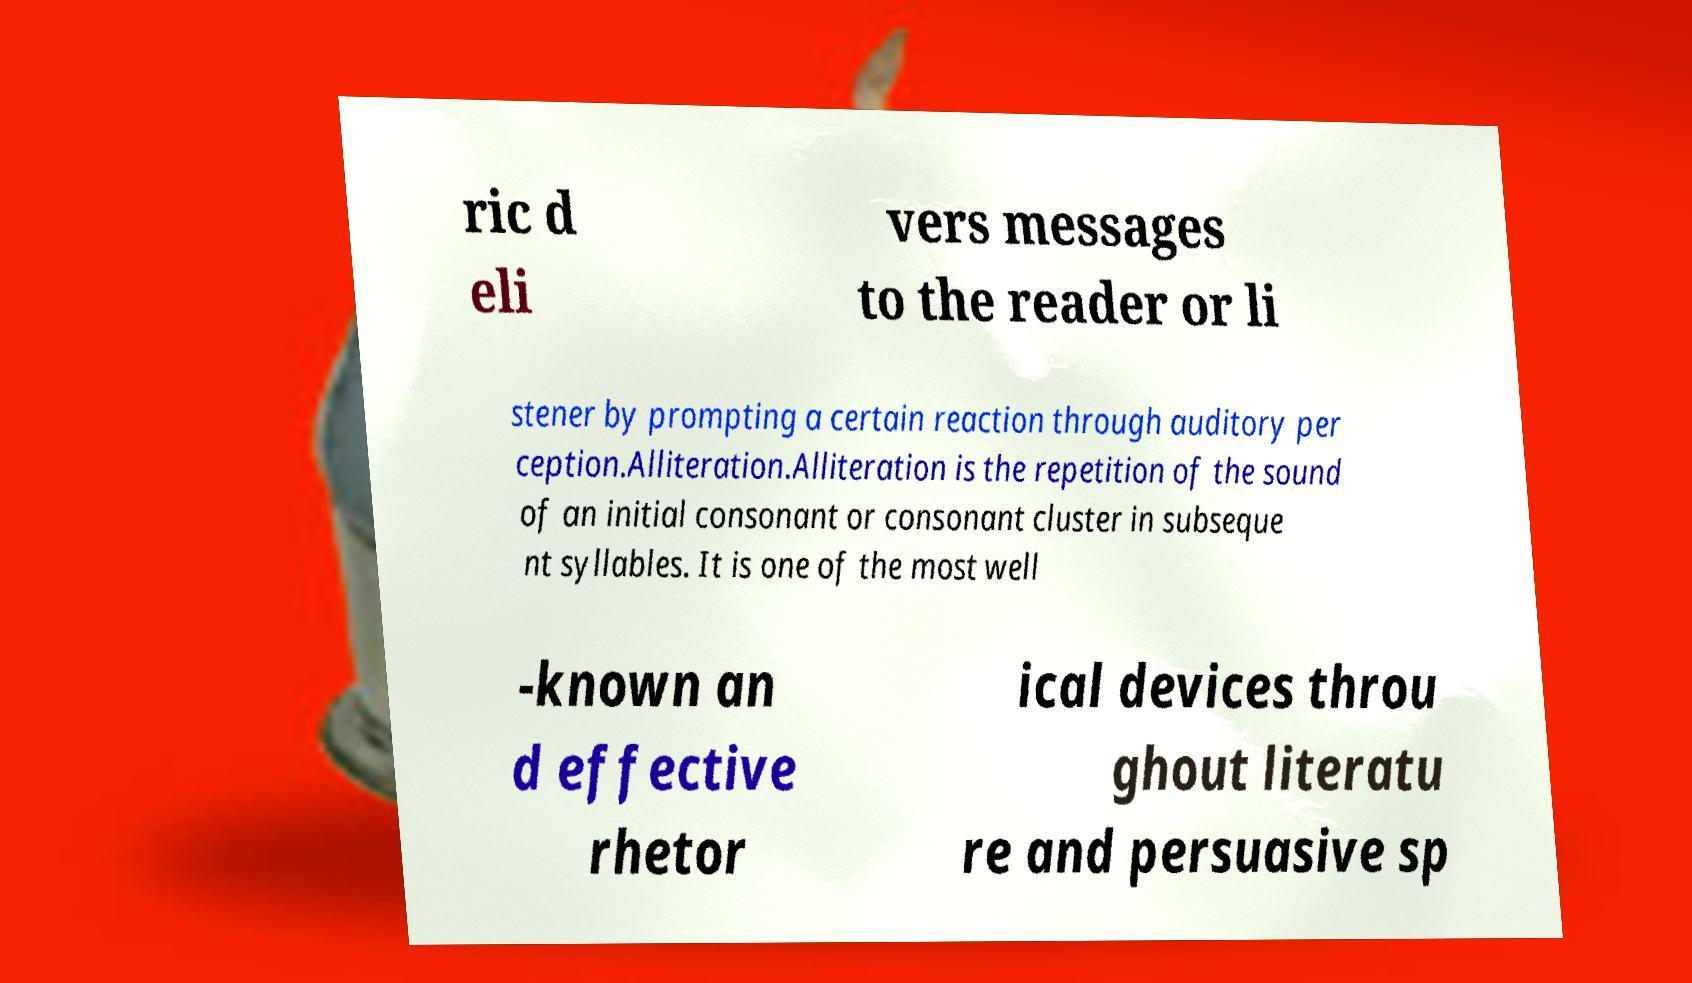I need the written content from this picture converted into text. Can you do that? ric d eli vers messages to the reader or li stener by prompting a certain reaction through auditory per ception.Alliteration.Alliteration is the repetition of the sound of an initial consonant or consonant cluster in subseque nt syllables. It is one of the most well -known an d effective rhetor ical devices throu ghout literatu re and persuasive sp 